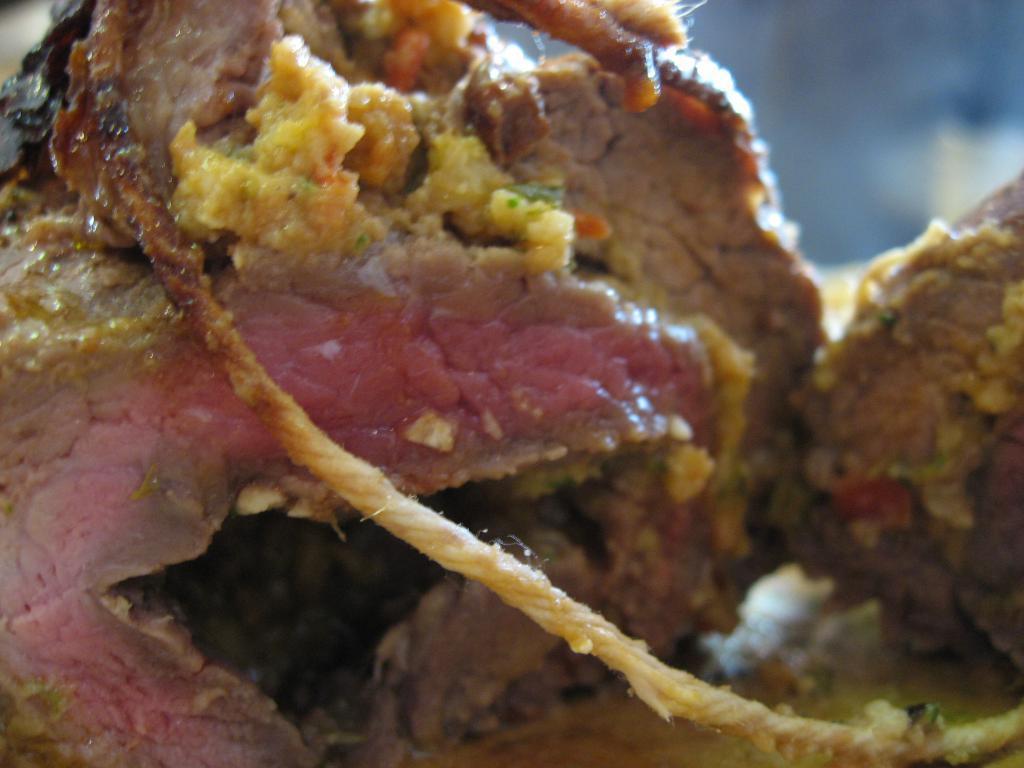In one or two sentences, can you explain what this image depicts? This picture shows meat and we see a thread. 